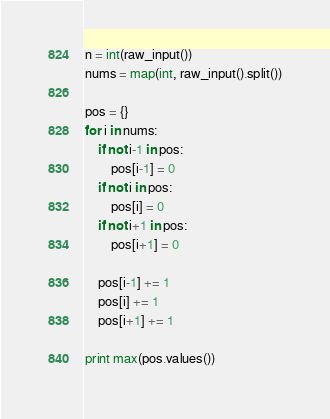<code> <loc_0><loc_0><loc_500><loc_500><_Python_>n = int(raw_input())
nums = map(int, raw_input().split())

pos = {}
for i in nums:
    if not i-1 in pos:
        pos[i-1] = 0
    if not i in pos:
        pos[i] = 0
    if not i+1 in pos:
        pos[i+1] = 0

    pos[i-1] += 1
    pos[i] += 1
    pos[i+1] += 1

print max(pos.values())
</code> 